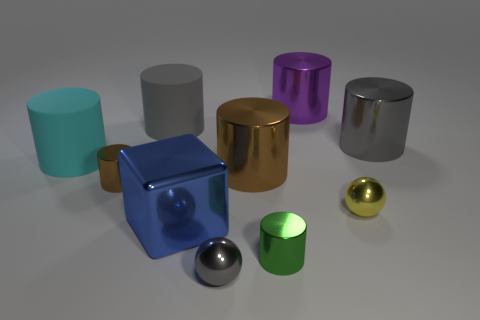Subtract all cyan cylinders. How many cylinders are left? 6 Subtract 1 cubes. How many cubes are left? 0 Subtract all balls. How many objects are left? 8 Subtract all gray balls. How many balls are left? 1 Subtract all yellow spheres. Subtract all red cylinders. How many spheres are left? 1 Subtract all red blocks. How many yellow balls are left? 1 Subtract all tiny purple shiny things. Subtract all large rubber objects. How many objects are left? 8 Add 4 big gray shiny cylinders. How many big gray shiny cylinders are left? 5 Add 7 big spheres. How many big spheres exist? 7 Subtract 0 green cubes. How many objects are left? 10 